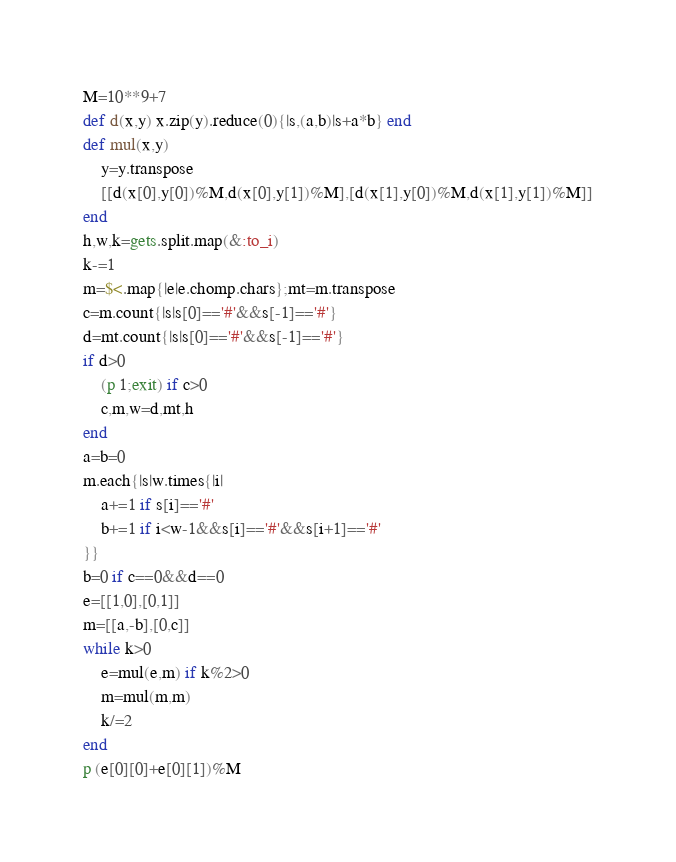Convert code to text. <code><loc_0><loc_0><loc_500><loc_500><_Ruby_>M=10**9+7
def d(x,y) x.zip(y).reduce(0){|s,(a,b)|s+a*b} end
def mul(x,y)
	y=y.transpose
	[[d(x[0],y[0])%M,d(x[0],y[1])%M],[d(x[1],y[0])%M,d(x[1],y[1])%M]]
end
h,w,k=gets.split.map(&:to_i)
k-=1
m=$<.map{|e|e.chomp.chars};mt=m.transpose
c=m.count{|s|s[0]=='#'&&s[-1]=='#'}
d=mt.count{|s|s[0]=='#'&&s[-1]=='#'}
if d>0
	(p 1;exit) if c>0
	c,m,w=d,mt,h
end
a=b=0
m.each{|s|w.times{|i|
	a+=1 if s[i]=='#'
	b+=1 if i<w-1&&s[i]=='#'&&s[i+1]=='#'
}}
b=0 if c==0&&d==0
e=[[1,0],[0,1]]
m=[[a,-b],[0,c]]
while k>0
	e=mul(e,m) if k%2>0
	m=mul(m,m)
	k/=2
end
p (e[0][0]+e[0][1])%M</code> 